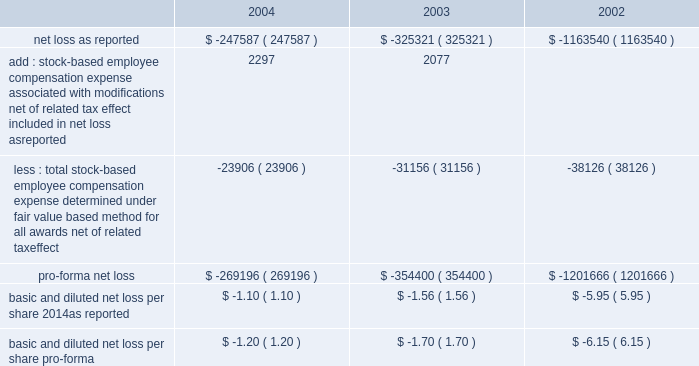American tower corporation and subsidiaries notes to consolidated financial statements 2014 ( continued ) stock-based compensation 2014the company complies with the provisions of sfas no .
148 , 201caccounting for stock-based compensation 2014transition and disclosure 2014an amendment of sfas no .
123 , 201d which provides optional transition guidance for those companies electing to voluntarily adopt the accounting provisions of sfas no .
123 .
The company continues to use accounting principles board opinion no .
25 ( apb no .
25 ) , 201caccounting for stock issued to employees , 201d to account for equity grants and awards to employees , officers and directors and has adopted the disclosure-only provisions of sfas no .
148 .
In accordance with apb no .
25 , the company recognizes compensation expense based on the excess , if any , of the quoted stock price at the grant date of the award or other measurement date over the amount an employee must pay to acquire the stock .
The company 2019s stock option plans are more fully described in note 13 .
In december 2004 , the fasb issued sfas no .
123r , 201cshare-based payment 201d ( sfas no .
123r ) , described below .
The table illustrates the effect on net loss and net loss per share if the company had applied the fair value recognition provisions of sfas no .
123 ( as amended ) to stock-based compensation .
The estimated fair value of each option is calculated using the black-scholes option-pricing model ( in thousands , except per share amounts ) : .
During the year ended december 31 , 2004 and 2003 , the company modified certain option awards to accelerate vesting and recorded charges of $ 3.0 million and $ 2.3 million , respectively , and corresponding increases to additional paid in capital in the accompanying consolidated financial statements .
Fair value of financial instruments 2014the carrying values of the company 2019s financial instruments , with the exception of long-term obligations , including current portion , reasonably approximate the related fair values as of december 31 , 2004 and 2003 .
As of december 31 , 2004 , the carrying amount and fair value of long-term obligations , including current portion , were $ 3.3 billion and $ 3.6 billion , respectively .
As of december 31 , 2003 , the carrying amount and fair value of long-term obligations , including current portion , were $ 3.4 billion and $ 3.6 billion , respectively .
Fair values are based primarily on quoted market prices for those or similar instruments .
Retirement plan 2014the company has a 401 ( k ) plan covering substantially all employees who meet certain age and employment requirements .
Under the plan , the company matching contribution for periods prior to june 30 , 2004 was 35% ( 35 % ) up to a maximum 5% ( 5 % ) of a participant 2019s contributions .
Effective july 1 , 2004 , the plan was amended to increase the company match to 50% ( 50 % ) up to a maximum 6% ( 6 % ) of a participant 2019s contributions .
The company contributed approximately $ 533000 , $ 825000 and $ 979000 to the plan for the years ended december 31 , 2004 , 2003 and 2002 , respectively .
Recent accounting pronouncements 2014in december 2004 , the fasb issued sfas no .
123r , which is a revision of sfas no .
123 , 201caccounting for stock-based compensation , 201d and supersedes apb no .
25 , accounting for .
As of december 31 , 2004 , what was the ratio of the the carrying amount to the fair value of long-term obligations? 
Computations: (3.3 / 3.6)
Answer: 0.91667. 